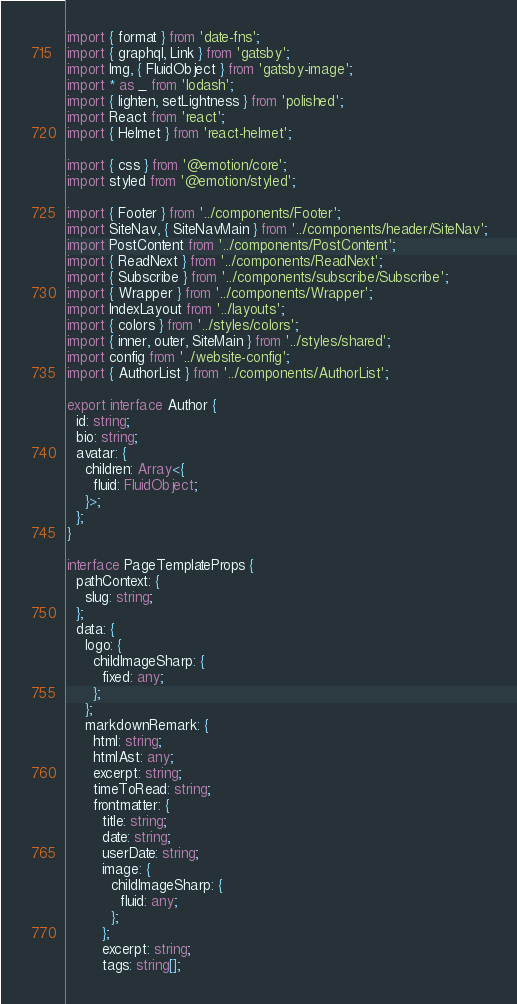<code> <loc_0><loc_0><loc_500><loc_500><_TypeScript_>import { format } from 'date-fns';
import { graphql, Link } from 'gatsby';
import Img, { FluidObject } from 'gatsby-image';
import * as _ from 'lodash';
import { lighten, setLightness } from 'polished';
import React from 'react';
import { Helmet } from 'react-helmet';

import { css } from '@emotion/core';
import styled from '@emotion/styled';

import { Footer } from '../components/Footer';
import SiteNav, { SiteNavMain } from '../components/header/SiteNav';
import PostContent from '../components/PostContent';
import { ReadNext } from '../components/ReadNext';
import { Subscribe } from '../components/subscribe/Subscribe';
import { Wrapper } from '../components/Wrapper';
import IndexLayout from '../layouts';
import { colors } from '../styles/colors';
import { inner, outer, SiteMain } from '../styles/shared';
import config from '../website-config';
import { AuthorList } from '../components/AuthorList';

export interface Author {
  id: string;
  bio: string;
  avatar: {
    children: Array<{
      fluid: FluidObject;
    }>;
  };
}

interface PageTemplateProps {
  pathContext: {
    slug: string;
  };
  data: {
    logo: {
      childImageSharp: {
        fixed: any;
      };
    };
    markdownRemark: {
      html: string;
      htmlAst: any;
      excerpt: string;
      timeToRead: string;
      frontmatter: {
        title: string;
        date: string;
        userDate: string;
        image: {
          childImageSharp: {
            fluid: any;
          };
        };
        excerpt: string;
        tags: string[];</code> 